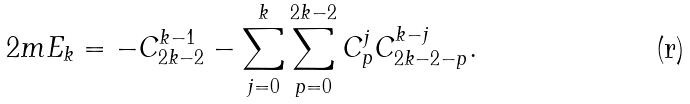Convert formula to latex. <formula><loc_0><loc_0><loc_500><loc_500>2 m E _ { k } = - C ^ { k - 1 } _ { 2 k - 2 } - \sum _ { j = 0 } ^ { k } \sum _ { p = 0 } ^ { 2 k - 2 } C ^ { j } _ { p } C ^ { k - j } _ { 2 k - 2 - p } .</formula> 